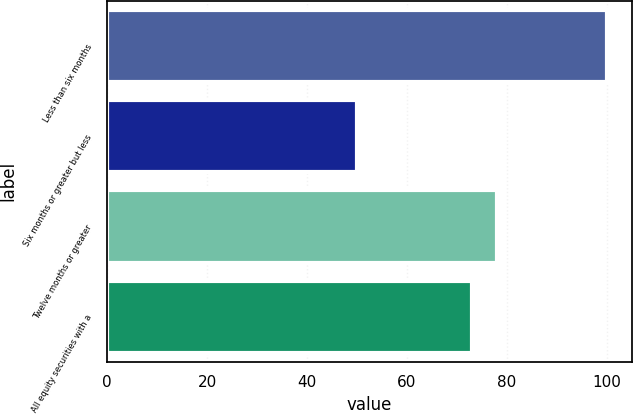<chart> <loc_0><loc_0><loc_500><loc_500><bar_chart><fcel>Less than six months<fcel>Six months or greater but less<fcel>Twelve months or greater<fcel>All equity securities with a<nl><fcel>100<fcel>50<fcel>78<fcel>73<nl></chart> 